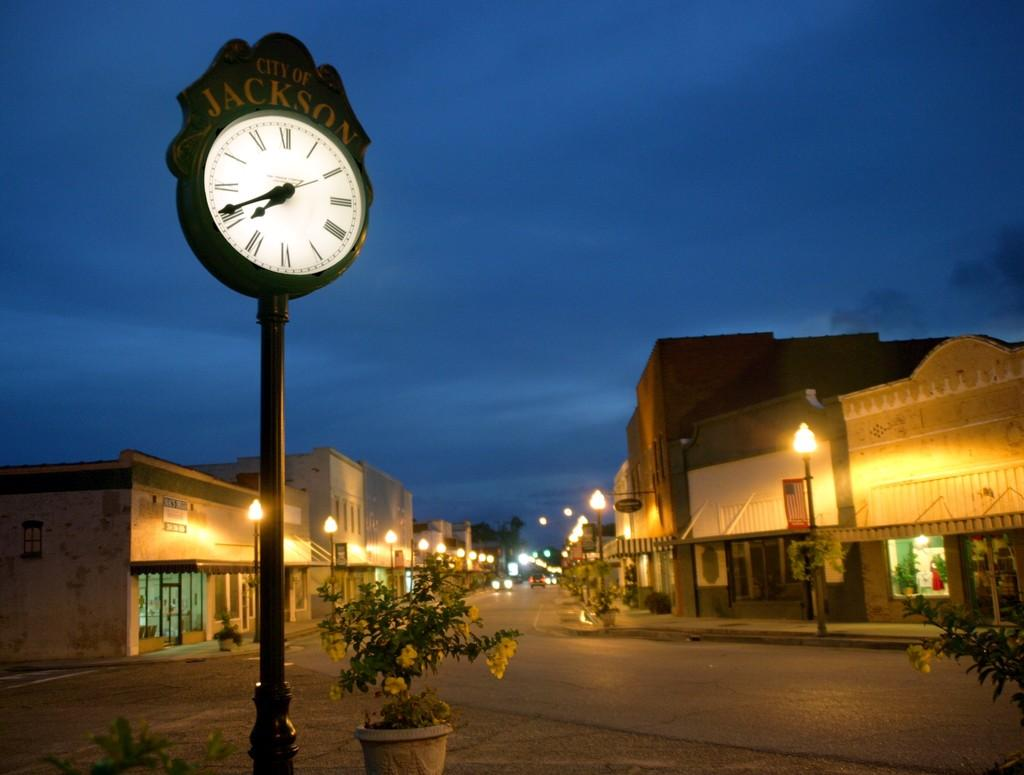<image>
Create a compact narrative representing the image presented. A clock in the town square of the City of Jackson indicates the time. 